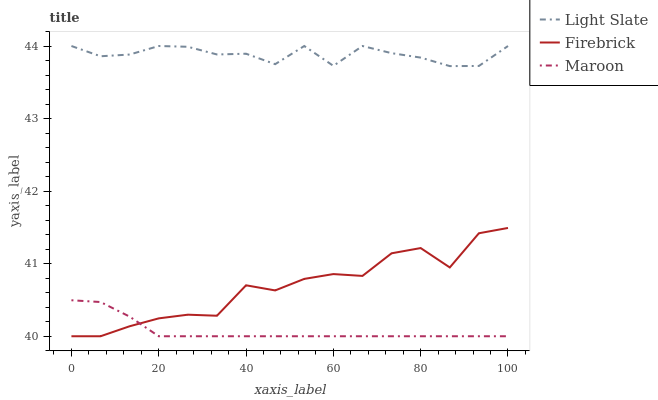Does Maroon have the minimum area under the curve?
Answer yes or no. Yes. Does Light Slate have the maximum area under the curve?
Answer yes or no. Yes. Does Firebrick have the minimum area under the curve?
Answer yes or no. No. Does Firebrick have the maximum area under the curve?
Answer yes or no. No. Is Maroon the smoothest?
Answer yes or no. Yes. Is Firebrick the roughest?
Answer yes or no. Yes. Is Firebrick the smoothest?
Answer yes or no. No. Is Maroon the roughest?
Answer yes or no. No. Does Light Slate have the highest value?
Answer yes or no. Yes. Does Firebrick have the highest value?
Answer yes or no. No. Is Firebrick less than Light Slate?
Answer yes or no. Yes. Is Light Slate greater than Firebrick?
Answer yes or no. Yes. Does Maroon intersect Firebrick?
Answer yes or no. Yes. Is Maroon less than Firebrick?
Answer yes or no. No. Is Maroon greater than Firebrick?
Answer yes or no. No. Does Firebrick intersect Light Slate?
Answer yes or no. No. 